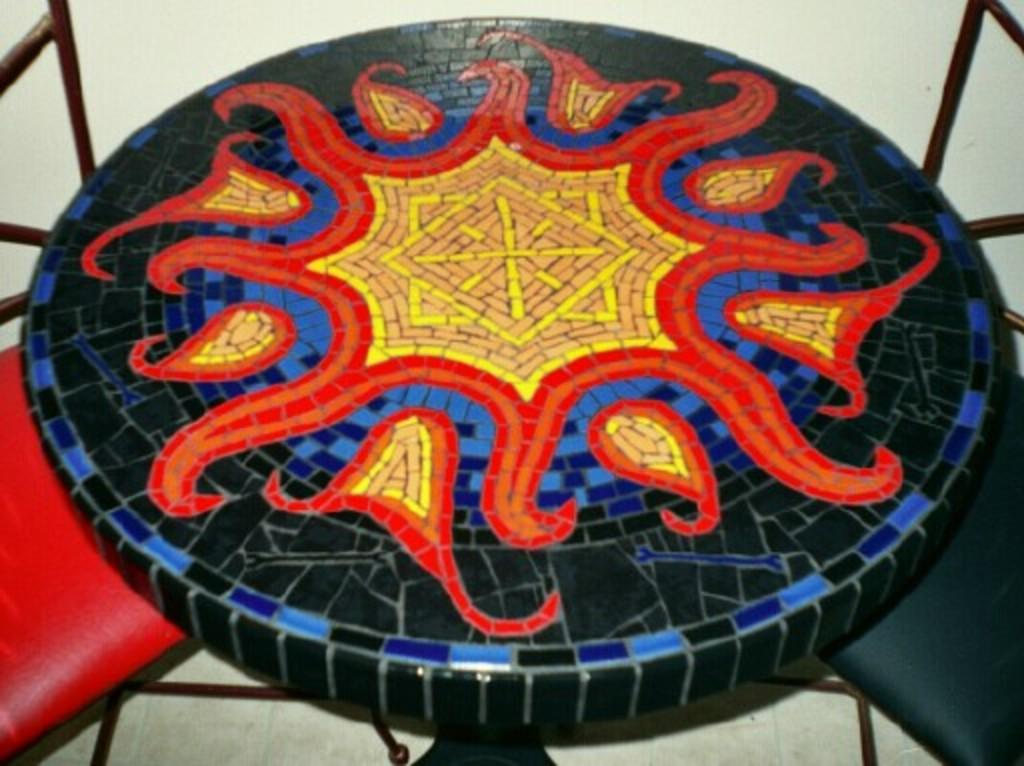What type of furniture is present in the image? There are chairs in the image. What is on the table can be considered a form of art? There is a painting on a table in the image. What color is the background of the image? The background of the image is white. How many dogs are sitting on the chairs in the image? There are no dogs present in the image; only chairs and a painting on a table are visible. What type of finger can be seen interacting with the painting in the image? There are no fingers visible in the image; only chairs, a painting, and a table are present. 